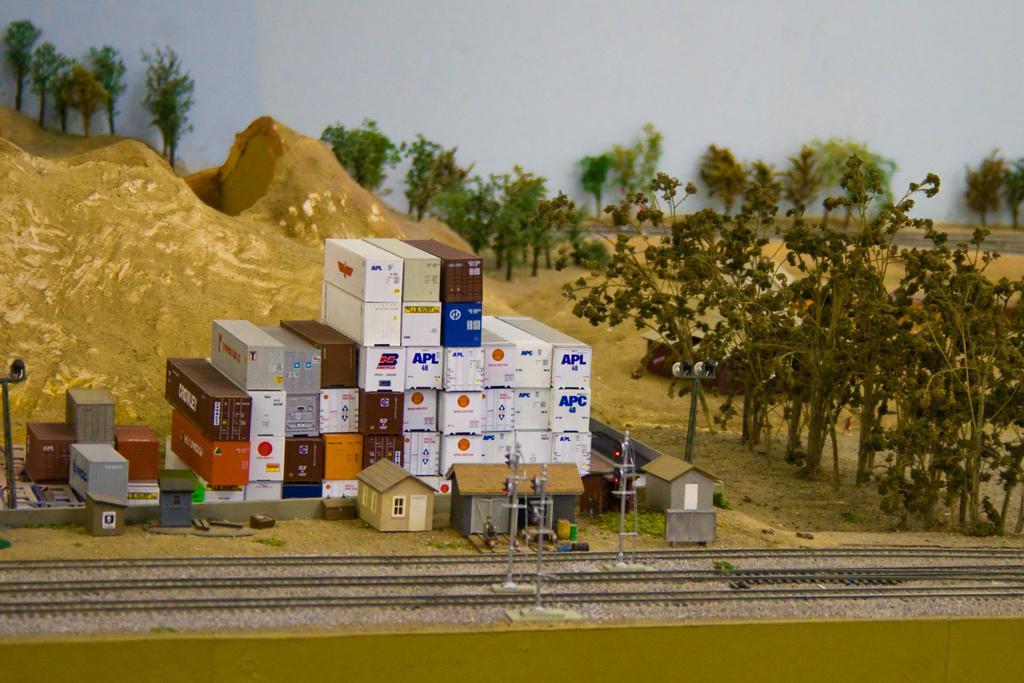Please provide a concise description of this image. In this image it looks like a miniature world in which there is a railway track at the bottom. Beside the railway track there are truck carriage which are kept one above the other. On the right side there are trees. In the background there are hills. In the middle there is a signal light in between both the tracks. 